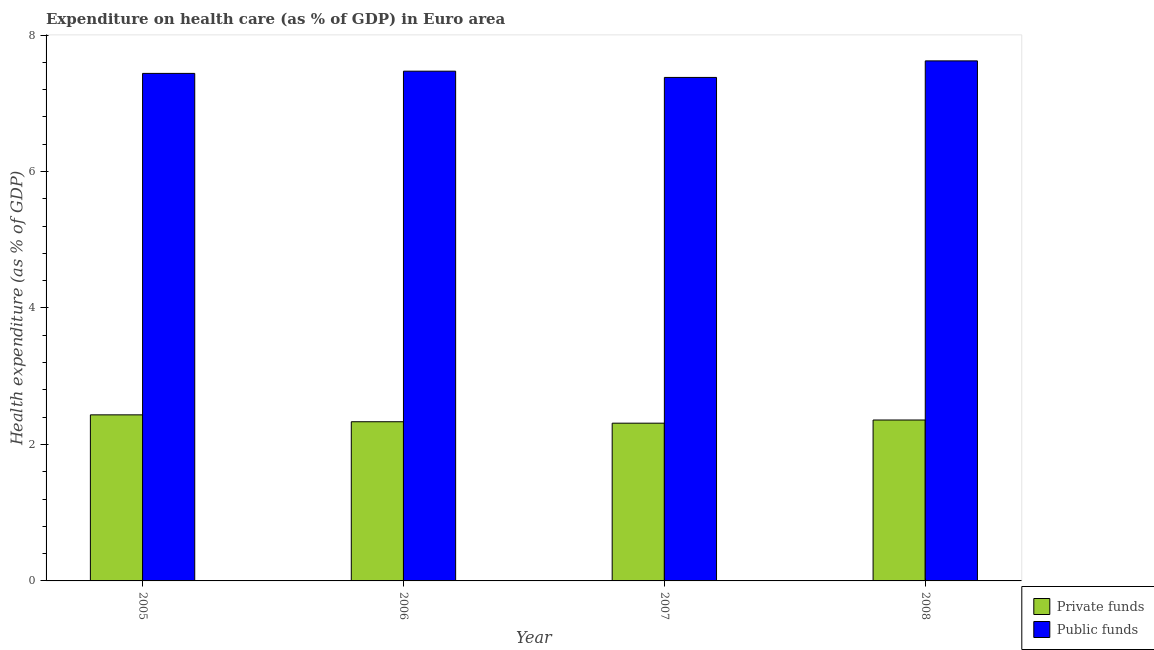How many different coloured bars are there?
Give a very brief answer. 2. How many groups of bars are there?
Your response must be concise. 4. What is the label of the 3rd group of bars from the left?
Provide a short and direct response. 2007. In how many cases, is the number of bars for a given year not equal to the number of legend labels?
Keep it short and to the point. 0. What is the amount of public funds spent in healthcare in 2008?
Your answer should be very brief. 7.62. Across all years, what is the maximum amount of private funds spent in healthcare?
Provide a succinct answer. 2.43. Across all years, what is the minimum amount of private funds spent in healthcare?
Your answer should be compact. 2.31. What is the total amount of private funds spent in healthcare in the graph?
Give a very brief answer. 9.44. What is the difference between the amount of private funds spent in healthcare in 2006 and that in 2007?
Your response must be concise. 0.02. What is the difference between the amount of public funds spent in healthcare in 2005 and the amount of private funds spent in healthcare in 2008?
Offer a very short reply. -0.18. What is the average amount of public funds spent in healthcare per year?
Offer a terse response. 7.48. In how many years, is the amount of public funds spent in healthcare greater than 3.6 %?
Give a very brief answer. 4. What is the ratio of the amount of public funds spent in healthcare in 2005 to that in 2008?
Ensure brevity in your answer.  0.98. What is the difference between the highest and the second highest amount of public funds spent in healthcare?
Your answer should be compact. 0.15. What is the difference between the highest and the lowest amount of public funds spent in healthcare?
Ensure brevity in your answer.  0.24. In how many years, is the amount of public funds spent in healthcare greater than the average amount of public funds spent in healthcare taken over all years?
Give a very brief answer. 1. Is the sum of the amount of private funds spent in healthcare in 2005 and 2007 greater than the maximum amount of public funds spent in healthcare across all years?
Keep it short and to the point. Yes. What does the 1st bar from the left in 2006 represents?
Offer a very short reply. Private funds. What does the 2nd bar from the right in 2008 represents?
Keep it short and to the point. Private funds. How many bars are there?
Ensure brevity in your answer.  8. Are all the bars in the graph horizontal?
Provide a short and direct response. No. What is the difference between two consecutive major ticks on the Y-axis?
Offer a terse response. 2. Are the values on the major ticks of Y-axis written in scientific E-notation?
Give a very brief answer. No. Where does the legend appear in the graph?
Make the answer very short. Bottom right. What is the title of the graph?
Keep it short and to the point. Expenditure on health care (as % of GDP) in Euro area. What is the label or title of the Y-axis?
Ensure brevity in your answer.  Health expenditure (as % of GDP). What is the Health expenditure (as % of GDP) in Private funds in 2005?
Ensure brevity in your answer.  2.43. What is the Health expenditure (as % of GDP) in Public funds in 2005?
Offer a very short reply. 7.44. What is the Health expenditure (as % of GDP) in Private funds in 2006?
Provide a succinct answer. 2.33. What is the Health expenditure (as % of GDP) in Public funds in 2006?
Offer a terse response. 7.47. What is the Health expenditure (as % of GDP) in Private funds in 2007?
Ensure brevity in your answer.  2.31. What is the Health expenditure (as % of GDP) in Public funds in 2007?
Your response must be concise. 7.38. What is the Health expenditure (as % of GDP) of Private funds in 2008?
Keep it short and to the point. 2.36. What is the Health expenditure (as % of GDP) in Public funds in 2008?
Your answer should be compact. 7.62. Across all years, what is the maximum Health expenditure (as % of GDP) in Private funds?
Keep it short and to the point. 2.43. Across all years, what is the maximum Health expenditure (as % of GDP) of Public funds?
Make the answer very short. 7.62. Across all years, what is the minimum Health expenditure (as % of GDP) in Private funds?
Keep it short and to the point. 2.31. Across all years, what is the minimum Health expenditure (as % of GDP) in Public funds?
Your response must be concise. 7.38. What is the total Health expenditure (as % of GDP) in Private funds in the graph?
Offer a very short reply. 9.44. What is the total Health expenditure (as % of GDP) in Public funds in the graph?
Make the answer very short. 29.91. What is the difference between the Health expenditure (as % of GDP) in Private funds in 2005 and that in 2006?
Keep it short and to the point. 0.1. What is the difference between the Health expenditure (as % of GDP) of Public funds in 2005 and that in 2006?
Make the answer very short. -0.03. What is the difference between the Health expenditure (as % of GDP) in Private funds in 2005 and that in 2007?
Your answer should be compact. 0.12. What is the difference between the Health expenditure (as % of GDP) in Public funds in 2005 and that in 2007?
Offer a very short reply. 0.06. What is the difference between the Health expenditure (as % of GDP) in Private funds in 2005 and that in 2008?
Provide a short and direct response. 0.08. What is the difference between the Health expenditure (as % of GDP) in Public funds in 2005 and that in 2008?
Offer a very short reply. -0.18. What is the difference between the Health expenditure (as % of GDP) in Private funds in 2006 and that in 2007?
Offer a terse response. 0.02. What is the difference between the Health expenditure (as % of GDP) in Public funds in 2006 and that in 2007?
Provide a short and direct response. 0.09. What is the difference between the Health expenditure (as % of GDP) of Private funds in 2006 and that in 2008?
Your answer should be compact. -0.03. What is the difference between the Health expenditure (as % of GDP) of Public funds in 2006 and that in 2008?
Your answer should be very brief. -0.15. What is the difference between the Health expenditure (as % of GDP) in Private funds in 2007 and that in 2008?
Offer a very short reply. -0.05. What is the difference between the Health expenditure (as % of GDP) of Public funds in 2007 and that in 2008?
Provide a succinct answer. -0.24. What is the difference between the Health expenditure (as % of GDP) in Private funds in 2005 and the Health expenditure (as % of GDP) in Public funds in 2006?
Provide a succinct answer. -5.04. What is the difference between the Health expenditure (as % of GDP) in Private funds in 2005 and the Health expenditure (as % of GDP) in Public funds in 2007?
Give a very brief answer. -4.95. What is the difference between the Health expenditure (as % of GDP) in Private funds in 2005 and the Health expenditure (as % of GDP) in Public funds in 2008?
Ensure brevity in your answer.  -5.19. What is the difference between the Health expenditure (as % of GDP) in Private funds in 2006 and the Health expenditure (as % of GDP) in Public funds in 2007?
Offer a very short reply. -5.05. What is the difference between the Health expenditure (as % of GDP) of Private funds in 2006 and the Health expenditure (as % of GDP) of Public funds in 2008?
Your response must be concise. -5.29. What is the difference between the Health expenditure (as % of GDP) of Private funds in 2007 and the Health expenditure (as % of GDP) of Public funds in 2008?
Make the answer very short. -5.31. What is the average Health expenditure (as % of GDP) of Private funds per year?
Provide a succinct answer. 2.36. What is the average Health expenditure (as % of GDP) in Public funds per year?
Your response must be concise. 7.48. In the year 2005, what is the difference between the Health expenditure (as % of GDP) of Private funds and Health expenditure (as % of GDP) of Public funds?
Offer a very short reply. -5. In the year 2006, what is the difference between the Health expenditure (as % of GDP) in Private funds and Health expenditure (as % of GDP) in Public funds?
Keep it short and to the point. -5.14. In the year 2007, what is the difference between the Health expenditure (as % of GDP) in Private funds and Health expenditure (as % of GDP) in Public funds?
Provide a succinct answer. -5.07. In the year 2008, what is the difference between the Health expenditure (as % of GDP) of Private funds and Health expenditure (as % of GDP) of Public funds?
Offer a very short reply. -5.26. What is the ratio of the Health expenditure (as % of GDP) of Private funds in 2005 to that in 2006?
Offer a terse response. 1.04. What is the ratio of the Health expenditure (as % of GDP) in Public funds in 2005 to that in 2006?
Give a very brief answer. 1. What is the ratio of the Health expenditure (as % of GDP) of Private funds in 2005 to that in 2007?
Provide a short and direct response. 1.05. What is the ratio of the Health expenditure (as % of GDP) of Public funds in 2005 to that in 2007?
Your answer should be very brief. 1.01. What is the ratio of the Health expenditure (as % of GDP) in Private funds in 2005 to that in 2008?
Your answer should be very brief. 1.03. What is the ratio of the Health expenditure (as % of GDP) of Public funds in 2005 to that in 2008?
Your answer should be compact. 0.98. What is the ratio of the Health expenditure (as % of GDP) in Private funds in 2006 to that in 2007?
Offer a terse response. 1.01. What is the ratio of the Health expenditure (as % of GDP) in Public funds in 2006 to that in 2007?
Provide a succinct answer. 1.01. What is the ratio of the Health expenditure (as % of GDP) in Private funds in 2006 to that in 2008?
Provide a succinct answer. 0.99. What is the ratio of the Health expenditure (as % of GDP) of Public funds in 2006 to that in 2008?
Your answer should be very brief. 0.98. What is the ratio of the Health expenditure (as % of GDP) in Private funds in 2007 to that in 2008?
Your answer should be compact. 0.98. What is the ratio of the Health expenditure (as % of GDP) in Public funds in 2007 to that in 2008?
Ensure brevity in your answer.  0.97. What is the difference between the highest and the second highest Health expenditure (as % of GDP) of Private funds?
Offer a very short reply. 0.08. What is the difference between the highest and the second highest Health expenditure (as % of GDP) in Public funds?
Offer a very short reply. 0.15. What is the difference between the highest and the lowest Health expenditure (as % of GDP) in Private funds?
Ensure brevity in your answer.  0.12. What is the difference between the highest and the lowest Health expenditure (as % of GDP) in Public funds?
Give a very brief answer. 0.24. 